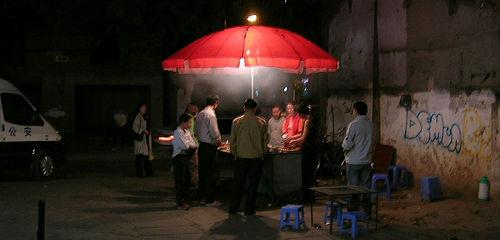What is happening under the umbrella? food sales 